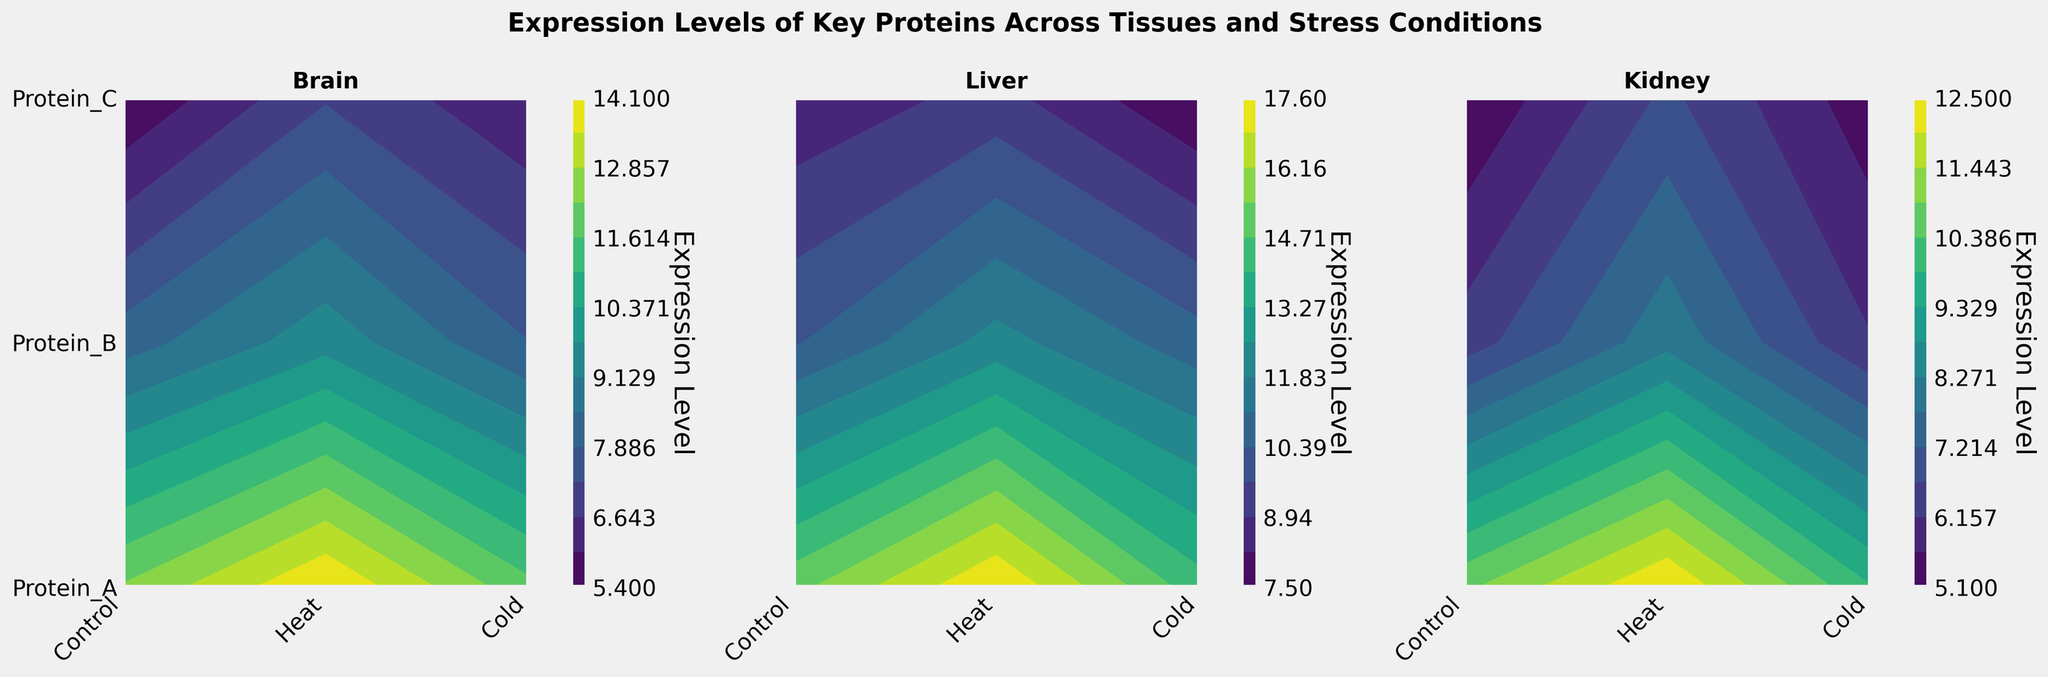What is the title of the figure? The title is located at the top center and gives an overview of what the figure is depicting.
Answer: Expression Levels of Key Proteins Across Tissues and Stress Conditions How many different tissues are represented in the figure? Each subplot represents one tissue, and there are three subplots in total.
Answer: 3 Which tissue has the highest expression level for Protein_A under heat stress? Identify the value levels in the heat stress condition for Protein_A in each subplot. The liver reaches the highest level.
Answer: Liver What is the range of expression levels shown in the figure? Contour plots usually encompass a range of data values depicted by colors. Observe the color bar, which displays the minimum and maximum expression levels.
Answer: 5.1 to 17.6 Which protein shows the least variation in expression levels across all conditions in the brain tissue? Examine the ranges of expression levels for all proteins across all conditions. Protein_C has the smallest range from 5.1 to 7.2.
Answer: Protein_C Compare the expression levels of Protein_B under cold stress between the liver and kidney tissues. Which one is higher? Locate the values of Protein_B under cold stress in both the liver and kidney tissue subplots. The liver has a higher value (10.7) compared to the kidney (6.2).
Answer: Liver What is the average expression level of Protein_C across all conditions in the brain tissue? Sum the expression levels of Protein_C in the brain tissue across all conditions and divide by the number of conditions. Calculations: (5.4 + 7.2 + 6.1) / 3.
Answer: 6.23 Which tissue shows the most significant increase in expression level for Protein_A from control to heat stress? Calculate the difference in expression levels for Protein_A between control and heat stress for each tissue and compare. The liver shows the most significant increase (from 15.2 to 17.6).
Answer: Liver Is there a stress condition where the expression level of Protein_B in the kidney is lower than in the brain for all conditions? Compare expression levels of Protein_B under control, heat, and cold conditions in both the kidney and brain. There is no such stress condition.
Answer: No 